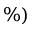Convert formula to latex. <formula><loc_0><loc_0><loc_500><loc_500>\% )</formula> 